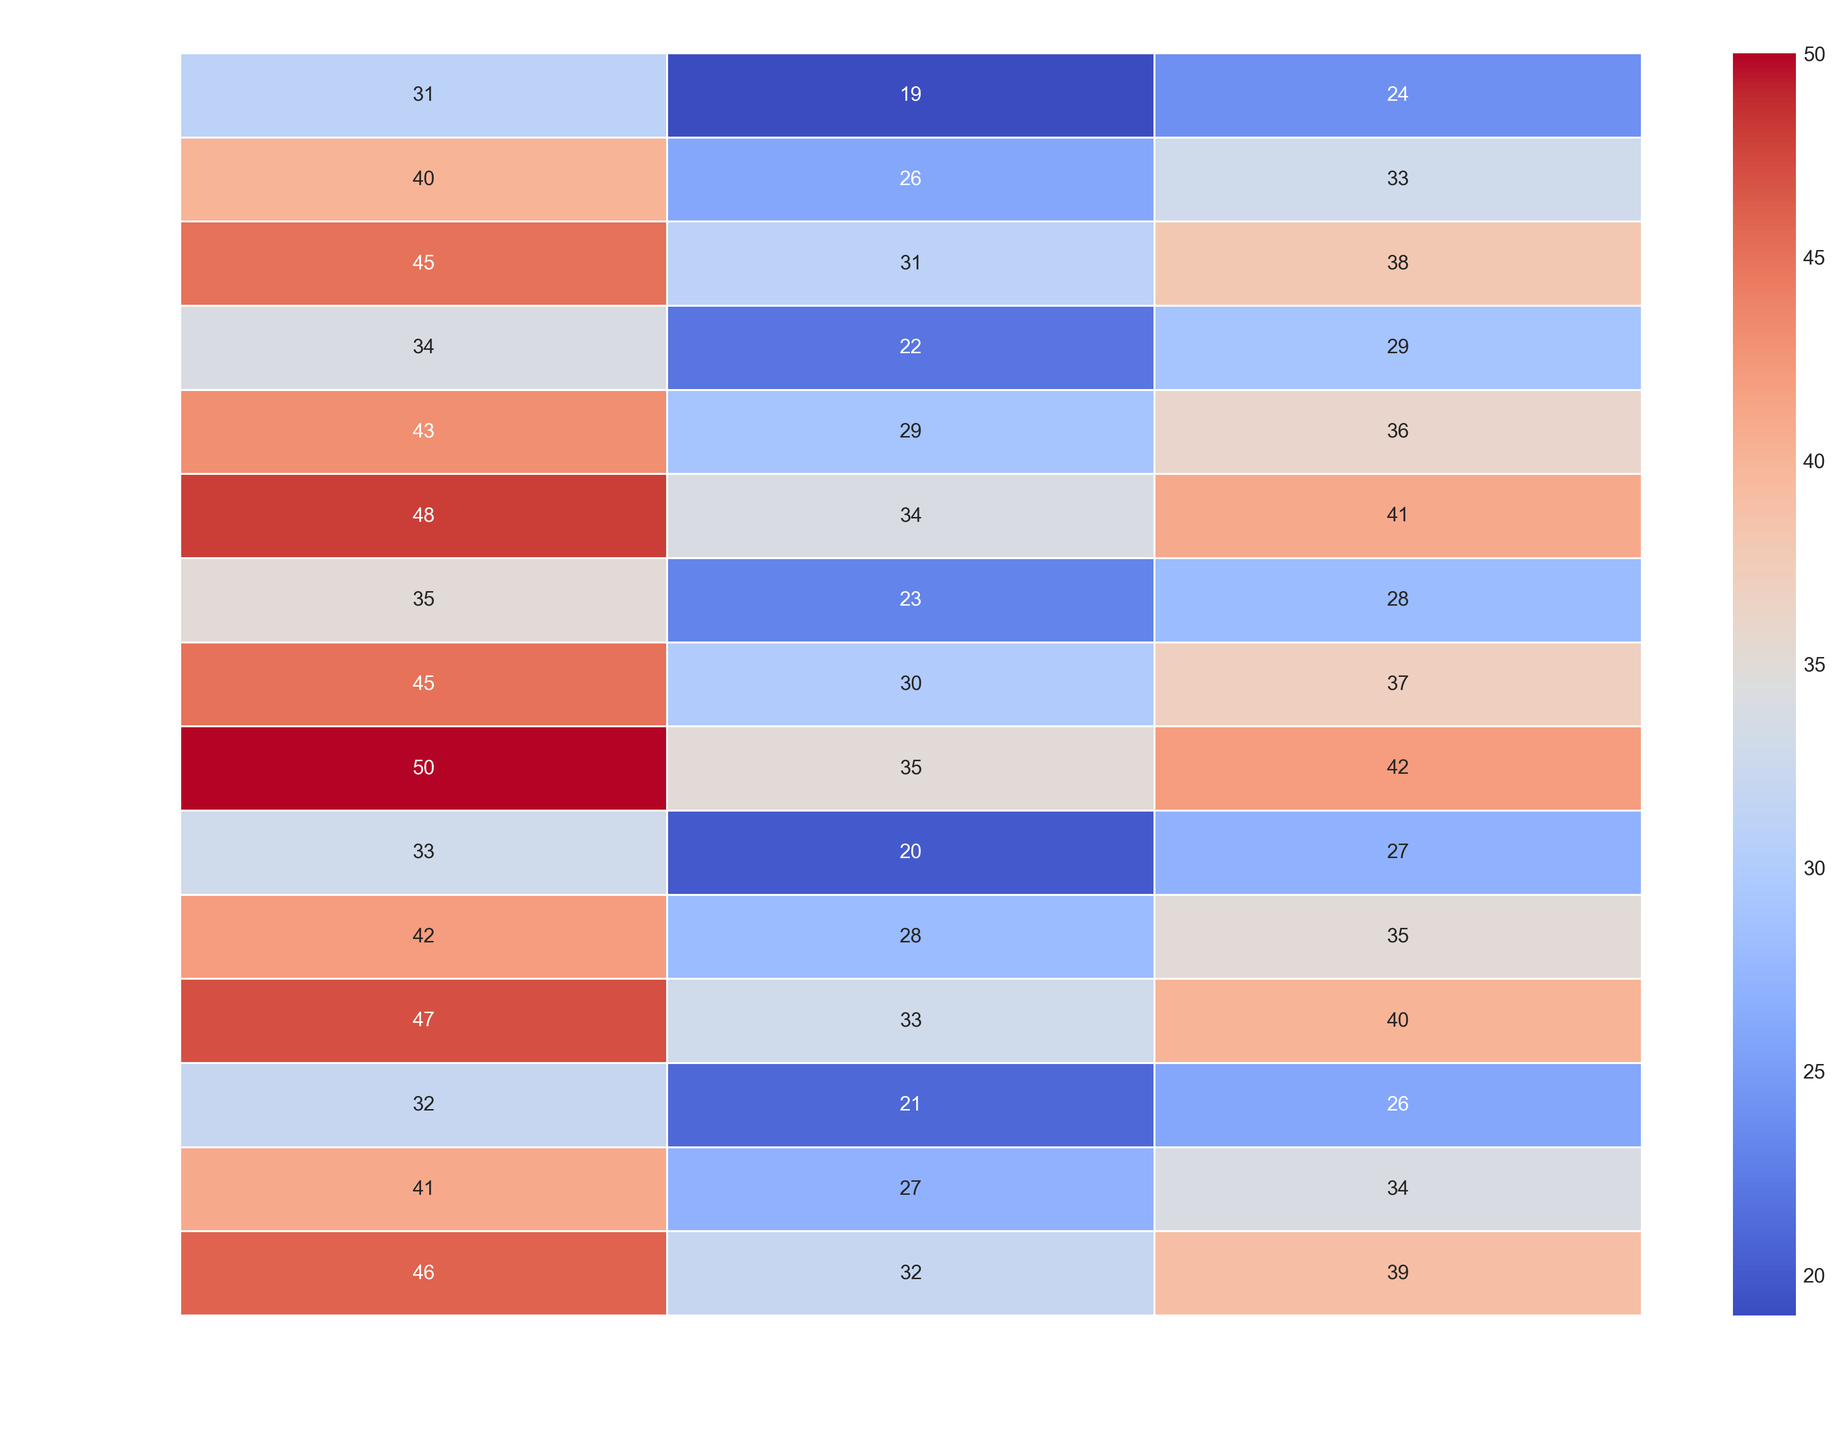Which region has the lowest Early Childhood Literacy (ECL) rate for infants aged 0-1 with Low socioeconomic status? By referring to the heatmap, we can look at the ECL rates for the 0-1 age group with Low socioeconomic status across different regions. The values are North (23), South (20), East (22), West (21), and Central (19). The lowest rate is 19 in the Central region.
Answer: Central Compare the ECL rates of children aged 2-3 with Middle socioeconomic status between the North and South regions. Which is higher? We can look at the respective ECL rates in the heatmap for children aged 2-3 with Middle socioeconomic status in the North and South regions. These are North (42) and South (40). Since 42 is greater than 40, the North region has a higher rate.
Answer: North Calculate the average ECL rate for children aged 1-2 from the East region across all socioeconomic statuses. First, identify the ECL rates in the heatmap for children aged 1-2 with Low, Middle, and High socioeconomic statuses in the East region: 29, 36, and 43 respectively. Adding these values gives 108. Dividing by the number of values (3), we get an average of 36.
Answer: 36 Which age group shows the greatest increase in ECL rate as the socioeconomic status improves in the West region? We need to determine the rate increase for each age group while shifting from Low to High socioeconomic status in the West region: 
0-1 (11), 1-2 (14), 2-3 (14). Both 1-2 and 2-3 groups show the greatest increase of 14.
Answer: 1-2, 2-3 Identify the region where children aged 2-3 from High socioeconomic status have the highest ECL rate. By looking at the heatmap values for the ECL rates of children aged 2-3 from High socioeconomic status, we observe:
North (50), South (47), East (48), West (46), Central (45). The highest rate is 50 in the North region.
Answer: North What is the difference in ECL rates between children from Low and High socioeconomic statuses in the Central region for the 1-2 age group? By referring to the heatmap, identify the values for Low (26) and High (40) socioeconomic statuses in the Central region for the 1-2 age group. The difference is 40 - 26 = 14.
Answer: 14 Compare the color intensity of the cells representing children aged 0-1 from High socioeconomic status in the North and East regions. Which one appears hotter (reddish)? A visual inspection of the heatmap reveals that the ECL rates for children aged 0-1 from High socioeconomic status are North (35) and East (34). The higher rate corresponds to brighter or hotter colors, so North appears hotter.
Answer: North Which age group in the South region has the smallest range of ECL rates across different socioeconomic statuses? We need to calculate the range for each age group in the South region:
0-1 (13), 1-2 (14), 2-3 (14). The smallest range is for the 0-1 age group.
Answer: 0-1 What is the average ECL rate for children aged 2-3 from Low socioeconomic status across all regions? Identify the values in the heatmap for the 2-3 age group with Low socioeconomic status across all regions:
North (35), South (33), East (34), West (32), Central (31). Adding these gives 165 and the average is 165 / 5 = 33.
Answer: 33 